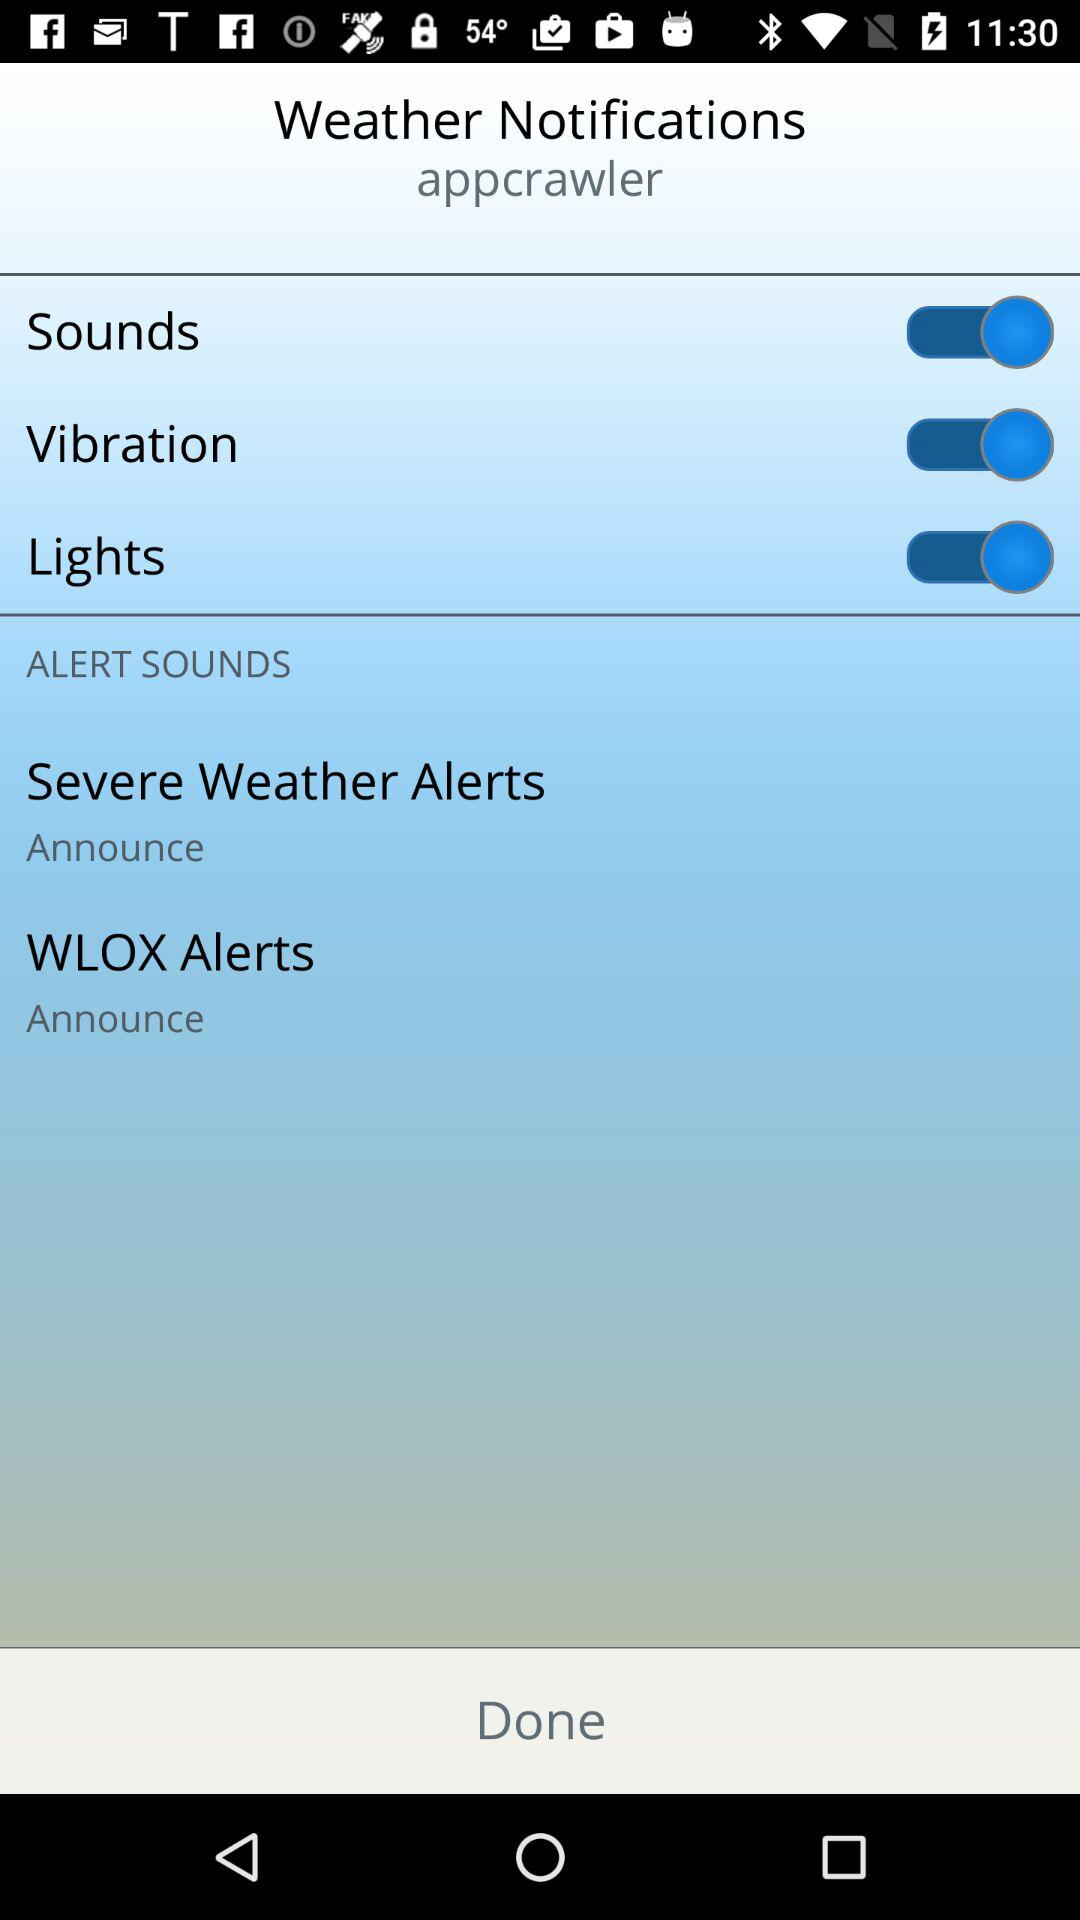What's the status of "Vibration"? The status is "on". 